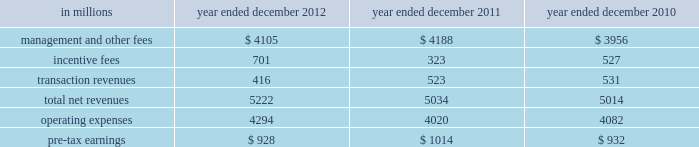Management 2019s discussion and analysis 2011 versus 2010 .
Net revenues in investing & lending were $ 2.14 billion and $ 7.54 billion for 2011 and 2010 , respectively .
During 2011 , investing & lending results reflected an operating environment characterized by a significant decline in equity markets in europe and asia , and unfavorable credit markets that were negatively impacted by increased concerns regarding the weakened state of global economies , including heightened european sovereign debt risk .
Results for 2011 included a loss of $ 517 million from our investment in the ordinary shares of icbc and net gains of $ 1.12 billion from other investments in equities , primarily in private equities , partially offset by losses from public equities .
In addition , investing & lending included net revenues of $ 96 million from debt securities and loans .
This amount includes approximately $ 1 billion of unrealized losses related to relationship lending activities , including the effect of hedges , offset by net interest income and net gains from other debt securities and loans .
Results for 2011 also included other net revenues of $ 1.44 billion , principally related to our consolidated investment entities .
Results for 2010 included a gain of $ 747 million from our investment in the ordinary shares of icbc , a net gain of $ 2.69 billion from other investments in equities , a net gain of $ 2.60 billion from debt securities and loans and other net revenues of $ 1.51 billion , principally related to our consolidated investment entities .
The net gain from other investments in equities was primarily driven by an increase in global equity markets , which resulted in appreciation of both our public and private equity positions and provided favorable conditions for initial public offerings .
The net gains and net interest from debt securities and loans primarily reflected the impact of tighter credit spreads and favorable credit markets during the year , which provided favorable conditions for borrowers to refinance .
Operating expenses were $ 2.67 billion for 2011 , 20% ( 20 % ) lower than 2010 , due to decreased compensation and benefits expenses , primarily resulting from lower net revenues .
This decrease was partially offset by the impact of impairment charges related to consolidated investments during 2011 .
Pre-tax loss was $ 531 million in 2011 , compared with pre-tax earnings of $ 4.18 billion in 2010 .
Investment management investment management provides investment management services and offers investment products ( primarily through separately managed accounts and commingled vehicles , such as mutual funds and private investment funds ) across all major asset classes to a diverse set of institutional and individual clients .
Investment management also offers wealth advisory services , including portfolio management and financial counseling , and brokerage and other transaction services to high-net-worth individuals and families .
Assets under supervision include assets under management and other client assets .
Assets under management include client assets where we earn a fee for managing assets on a discretionary basis .
This includes net assets in our mutual funds , hedge funds , credit funds and private equity funds ( including real estate funds ) , and separately managed accounts for institutional and individual investors .
Other client assets include client assets invested with third-party managers , private bank deposits and assets related to advisory relationships where we earn a fee for advisory and other services , but do not have discretion over the assets .
Assets under supervision do not include the self-directed brokerage accounts of our clients .
Assets under management and other client assets typically generate fees as a percentage of net asset value , which vary by asset class and are affected by investment performance as well as asset inflows and redemptions .
In certain circumstances , we are also entitled to receive incentive fees based on a percentage of a fund 2019s return or when the return exceeds a specified benchmark or other performance targets .
Incentive fees are recognized only when all material contingencies are resolved .
The table below presents the operating results of our investment management segment. .
56 goldman sachs 2012 annual report .
What percentage of total net revenues in the investment management segment in 2012 where due to management and other fees? 
Computations: (4105 / 5222)
Answer: 0.7861. 